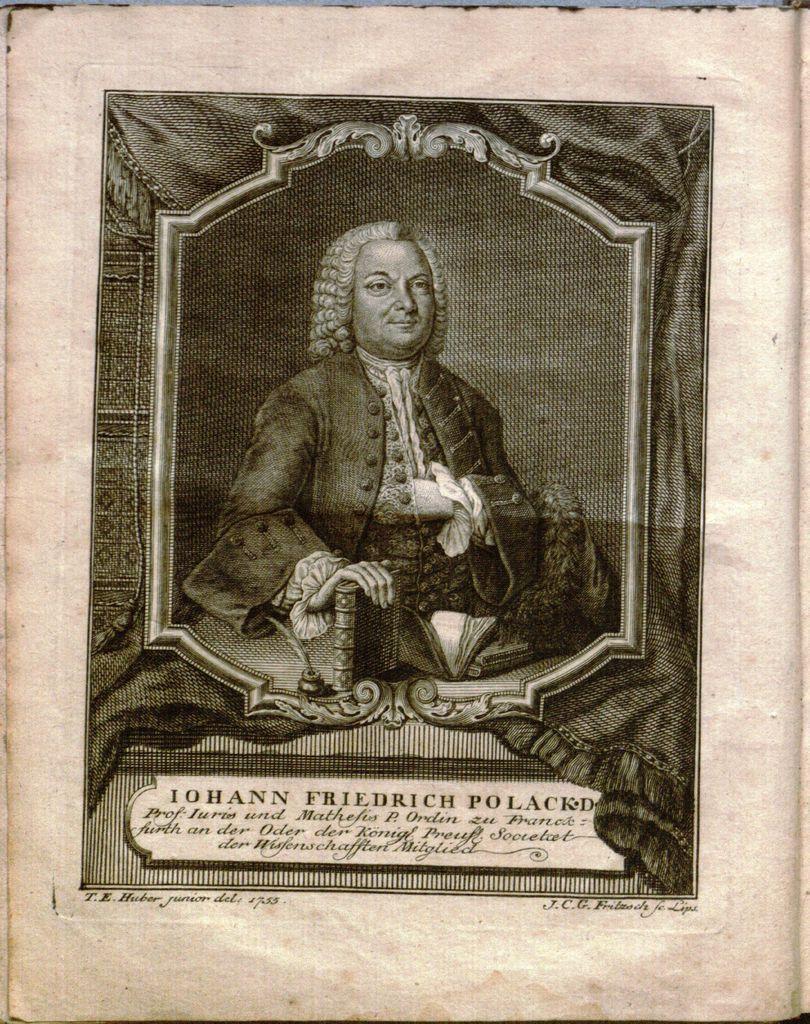How would you summarize this image in a sentence or two? In this image we can see the picture of a man and some text on the paper. 